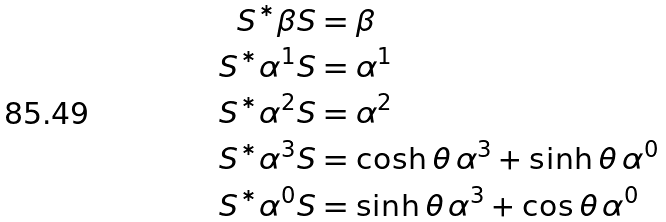Convert formula to latex. <formula><loc_0><loc_0><loc_500><loc_500>S ^ { * } \beta S & = \beta \\ S ^ { * } \alpha ^ { 1 } S & = \alpha ^ { 1 } \\ S ^ { * } \alpha ^ { 2 } S & = \alpha ^ { 2 } \\ S ^ { * } \alpha ^ { 3 } S & = \cosh \theta \, \alpha ^ { 3 } + \sinh \theta \, \alpha ^ { 0 } \\ S ^ { * } \alpha ^ { 0 } S & = \sinh \theta \, \alpha ^ { 3 } + \cos \theta \, \alpha ^ { 0 }</formula> 